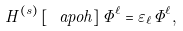Convert formula to latex. <formula><loc_0><loc_0><loc_500><loc_500>H ^ { ( s ) } \left [ \ a p o h \right ] \Phi ^ { \ell } = \varepsilon _ { \ell } \Phi ^ { \ell } ,</formula> 